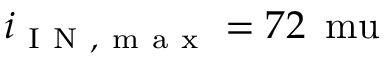Convert formula to latex. <formula><loc_0><loc_0><loc_500><loc_500>i _ { I N , m a x } = 7 2 \, \ m u</formula> 